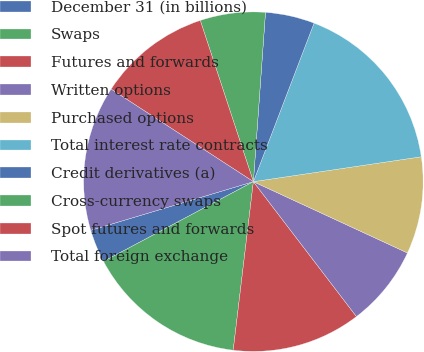Convert chart to OTSL. <chart><loc_0><loc_0><loc_500><loc_500><pie_chart><fcel>December 31 (in billions)<fcel>Swaps<fcel>Futures and forwards<fcel>Written options<fcel>Purchased options<fcel>Total interest rate contracts<fcel>Credit derivatives (a)<fcel>Cross-currency swaps<fcel>Spot futures and forwards<fcel>Total foreign exchange<nl><fcel>3.16%<fcel>15.32%<fcel>12.28%<fcel>7.72%<fcel>9.24%<fcel>16.84%<fcel>4.68%<fcel>6.2%<fcel>10.76%<fcel>13.8%<nl></chart> 